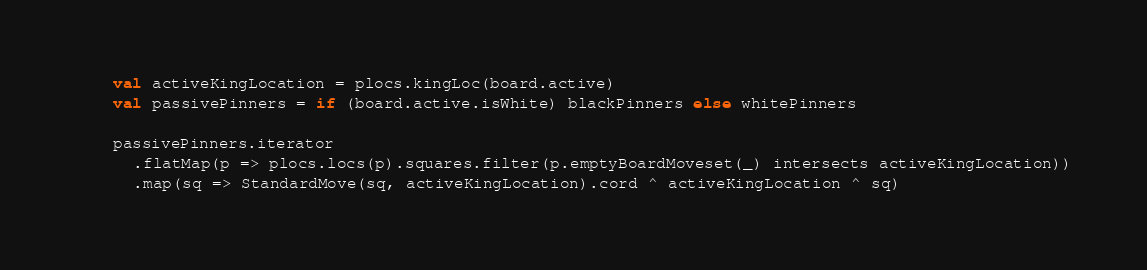Convert code to text. <code><loc_0><loc_0><loc_500><loc_500><_Scala_>    val activeKingLocation = plocs.kingLoc(board.active)
    val passivePinners = if (board.active.isWhite) blackPinners else whitePinners

    passivePinners.iterator
      .flatMap(p => plocs.locs(p).squares.filter(p.emptyBoardMoveset(_) intersects activeKingLocation))
      .map(sq => StandardMove(sq, activeKingLocation).cord ^ activeKingLocation ^ sq)</code> 